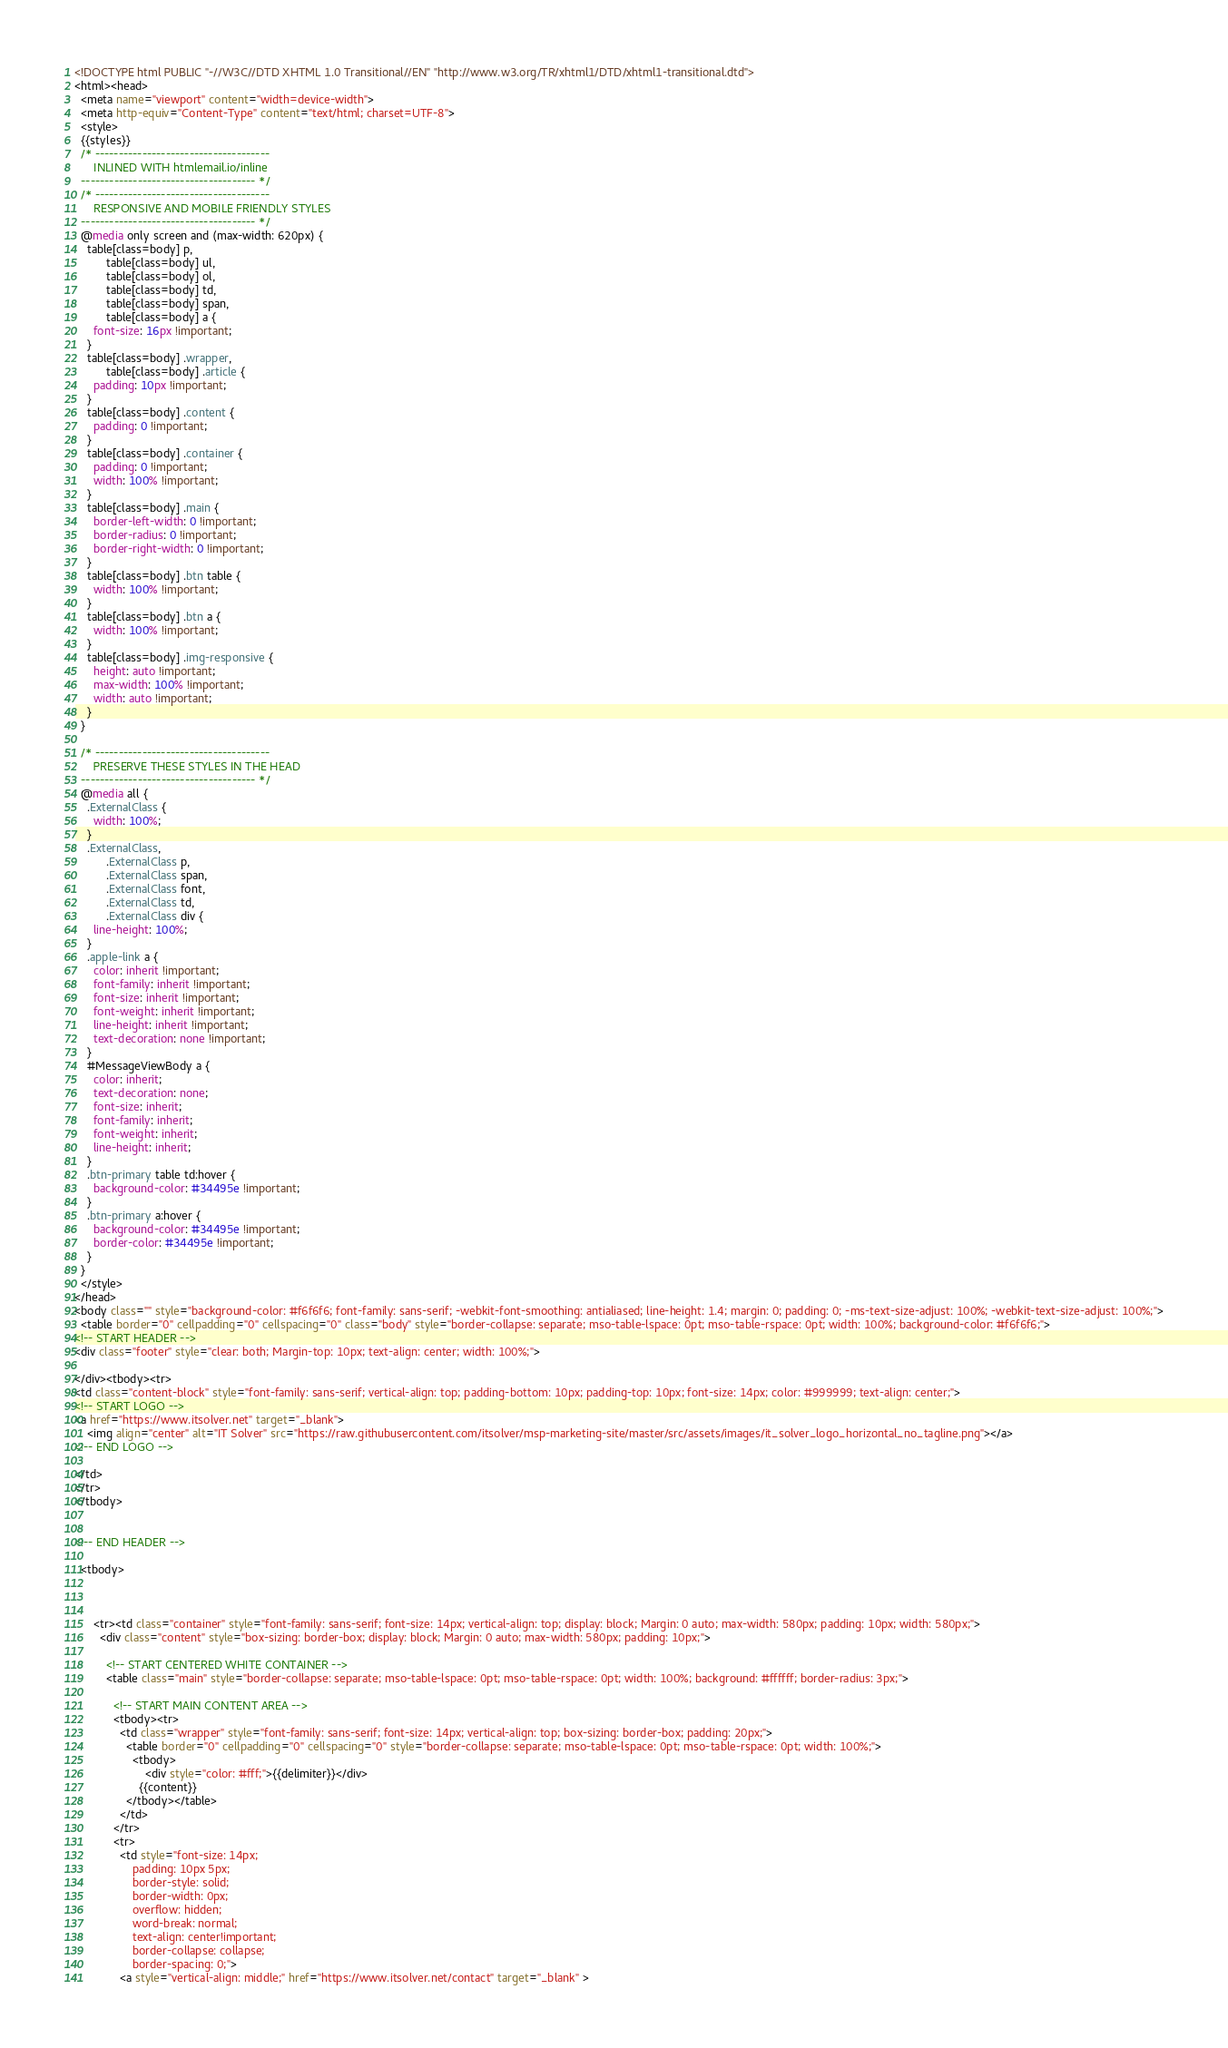<code> <loc_0><loc_0><loc_500><loc_500><_HTML_><!DOCTYPE html PUBLIC "-//W3C//DTD XHTML 1.0 Transitional//EN" "http://www.w3.org/TR/xhtml1/DTD/xhtml1-transitional.dtd">
<html><head>
  <meta name="viewport" content="width=device-width">
  <meta http-equiv="Content-Type" content="text/html; charset=UTF-8">
  <style>
  {{styles}}
  /* -------------------------------------
      INLINED WITH htmlemail.io/inline
  ------------------------------------- */
  /* -------------------------------------
      RESPONSIVE AND MOBILE FRIENDLY STYLES
  ------------------------------------- */
  @media only screen and (max-width: 620px) {
    table[class=body] p,
          table[class=body] ul,
          table[class=body] ol,
          table[class=body] td,
          table[class=body] span,
          table[class=body] a {
      font-size: 16px !important;
    }
    table[class=body] .wrapper,
          table[class=body] .article {
      padding: 10px !important;
    }
    table[class=body] .content {
      padding: 0 !important;
    }
    table[class=body] .container {
      padding: 0 !important;
      width: 100% !important;
    }
    table[class=body] .main {
      border-left-width: 0 !important;
      border-radius: 0 !important;
      border-right-width: 0 !important;
    }
    table[class=body] .btn table {
      width: 100% !important;
    }
    table[class=body] .btn a {
      width: 100% !important;
    }
    table[class=body] .img-responsive {
      height: auto !important;
      max-width: 100% !important;
      width: auto !important;
    }
  }

  /* -------------------------------------
      PRESERVE THESE STYLES IN THE HEAD
  ------------------------------------- */
  @media all {
    .ExternalClass {
      width: 100%;
    }
    .ExternalClass,
          .ExternalClass p,
          .ExternalClass span,
          .ExternalClass font,
          .ExternalClass td,
          .ExternalClass div {
      line-height: 100%;
    }
    .apple-link a {
      color: inherit !important;
      font-family: inherit !important;
      font-size: inherit !important;
      font-weight: inherit !important;
      line-height: inherit !important;
      text-decoration: none !important;
    }
    #MessageViewBody a {
      color: inherit;
      text-decoration: none;
      font-size: inherit;
      font-family: inherit;
      font-weight: inherit;
      line-height: inherit;
    }
    .btn-primary table td:hover {
      background-color: #34495e !important;
    }
    .btn-primary a:hover {
      background-color: #34495e !important;
      border-color: #34495e !important;
    }
  }
  </style>
</head>
<body class="" style="background-color: #f6f6f6; font-family: sans-serif; -webkit-font-smoothing: antialiased; line-height: 1.4; margin: 0; padding: 0; -ms-text-size-adjust: 100%; -webkit-text-size-adjust: 100%;">
  <table border="0" cellpadding="0" cellspacing="0" class="body" style="border-collapse: separate; mso-table-lspace: 0pt; mso-table-rspace: 0pt; width: 100%; background-color: #f6f6f6;">
<!-- START HEADER -->
<div class="footer" style="clear: both; Margin-top: 10px; text-align: center; width: 100%;">
            
</div><tbody><tr>
<td class="content-block" style="font-family: sans-serif; vertical-align: top; padding-bottom: 10px; padding-top: 10px; font-size: 14px; color: #999999; text-align: center;">
<!-- START LOGO -->
<a href="https://www.itsolver.net" target="_blank">
    <img align="center" alt="IT Solver" src="https://raw.githubusercontent.com/itsolver/msp-marketing-site/master/src/assets/images/it_solver_logo_horizontal_no_tagline.png"></a>
<!-- END LOGO -->

</td>
</tr>
</tbody>
          
  
<!-- END HEADER -->    
  
  <tbody>
              
            
          
      <tr><td class="container" style="font-family: sans-serif; font-size: 14px; vertical-align: top; display: block; Margin: 0 auto; max-width: 580px; padding: 10px; width: 580px;">
        <div class="content" style="box-sizing: border-box; display: block; Margin: 0 auto; max-width: 580px; padding: 10px;">
  
          <!-- START CENTERED WHITE CONTAINER -->
          <table class="main" style="border-collapse: separate; mso-table-lspace: 0pt; mso-table-rspace: 0pt; width: 100%; background: #ffffff; border-radius: 3px;">

            <!-- START MAIN CONTENT AREA -->
            <tbody><tr>
              <td class="wrapper" style="font-family: sans-serif; font-size: 14px; vertical-align: top; box-sizing: border-box; padding: 20px;">
                <table border="0" cellpadding="0" cellspacing="0" style="border-collapse: separate; mso-table-lspace: 0pt; mso-table-rspace: 0pt; width: 100%;">
                  <tbody>
                      <div style="color: #fff;">{{delimiter}}</div>
                    {{content}}
                </tbody></table>
              </td>
            </tr>
            <tr>
              <td style="font-size: 14px;
                  padding: 10px 5px;
                  border-style: solid;
                  border-width: 0px;
                  overflow: hidden;
                  word-break: normal;
                  text-align: center!important;    
                  border-collapse: collapse;
                  border-spacing: 0;">
              <a style="vertical-align: middle;" href="https://www.itsolver.net/contact" target="_blank" ></code> 